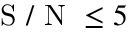Convert formula to latex. <formula><loc_0><loc_0><loc_500><loc_500>S / N \leq 5</formula> 